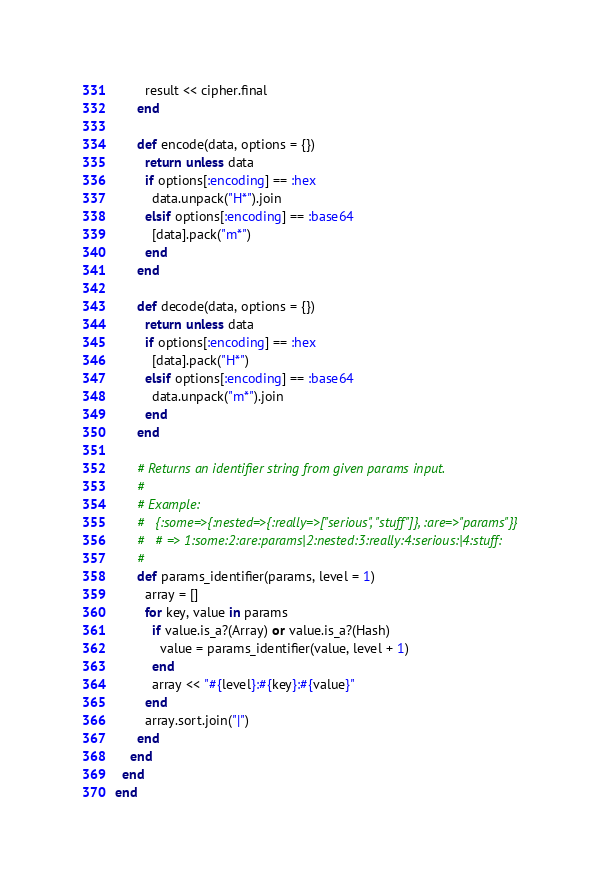<code> <loc_0><loc_0><loc_500><loc_500><_Ruby_>        result << cipher.final
      end

      def encode(data, options = {})
        return unless data
        if options[:encoding] == :hex
          data.unpack("H*").join
        elsif options[:encoding] == :base64
          [data].pack("m*")
        end
      end

      def decode(data, options = {})
        return unless data
        if options[:encoding] == :hex
          [data].pack("H*")
        elsif options[:encoding] == :base64
          data.unpack("m*").join
        end
      end

      # Returns an identifier string from given params input.
      #
      # Example:
      #   {:some=>{:nested=>{:really=>["serious", "stuff"]}, :are=>"params"}}
      #   # => 1:some:2:are:params|2:nested:3:really:4:serious:|4:stuff:
      #
      def params_identifier(params, level = 1)
        array = []
        for key, value in params
          if value.is_a?(Array) or value.is_a?(Hash)
            value = params_identifier(value, level + 1)
          end
          array << "#{level}:#{key}:#{value}"
        end
        array.sort.join("|")
      end
    end
  end
end
</code> 